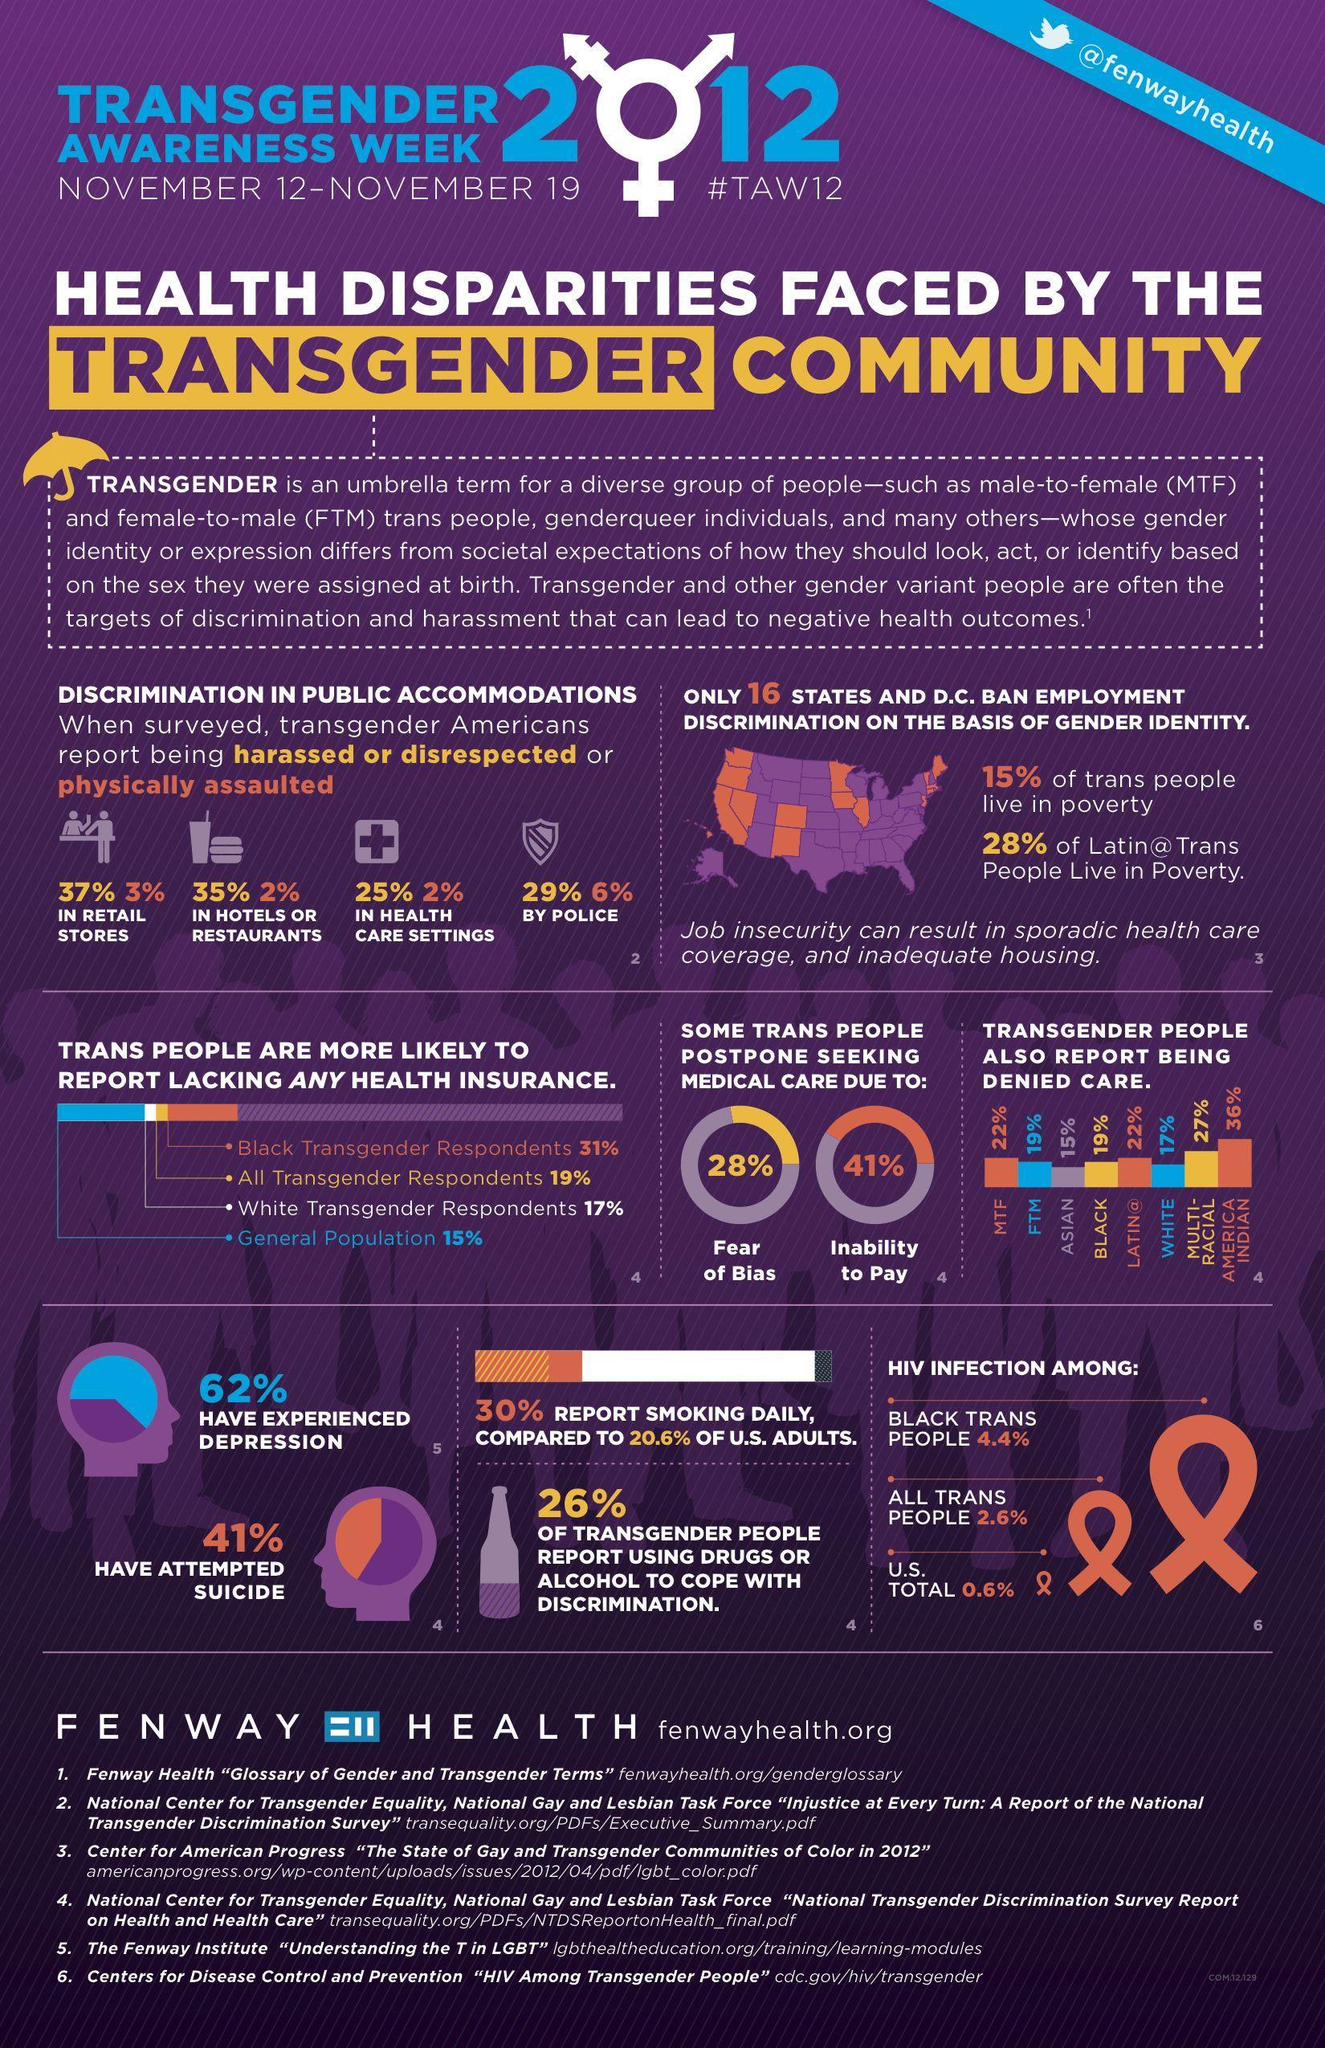What was used by 26% of transgenders to cope with bias?
Answer the question with a short phrase. drugs or alcohol how many of the transgenders reported physical assault by police? 6% Why do 41% of transgenders postpone medical care? inability to pay what is the reason for 28% of transgenders to postpone medical care? fear of bias What was reported by 35% of transgenders in hotels or restaurants? being harassed or disrespected 